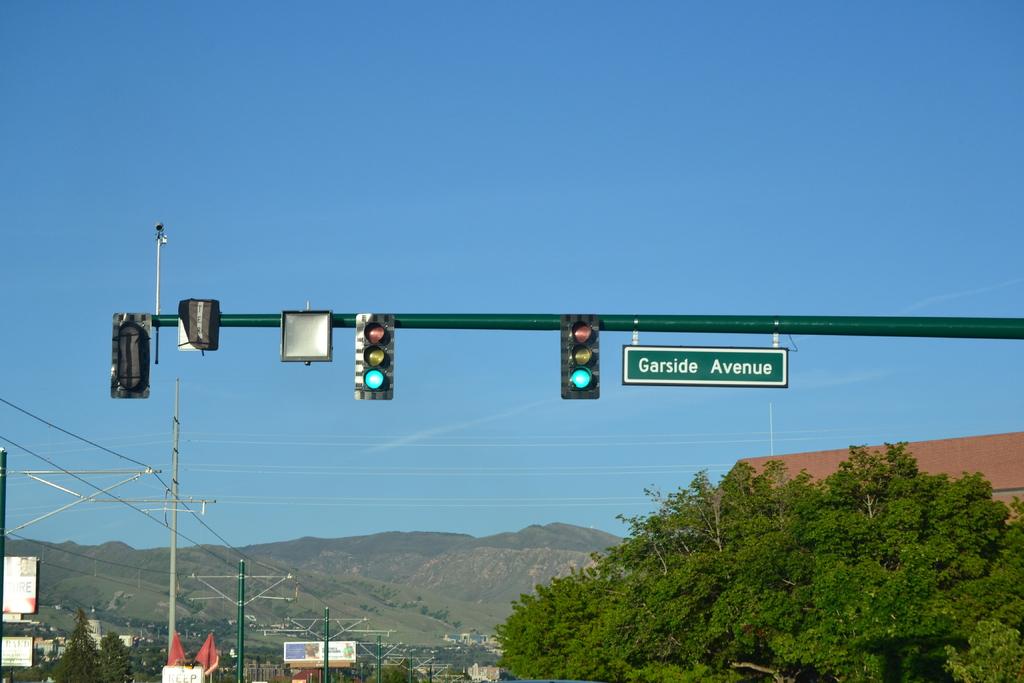What street is this?
Give a very brief answer. Garside avenue. 